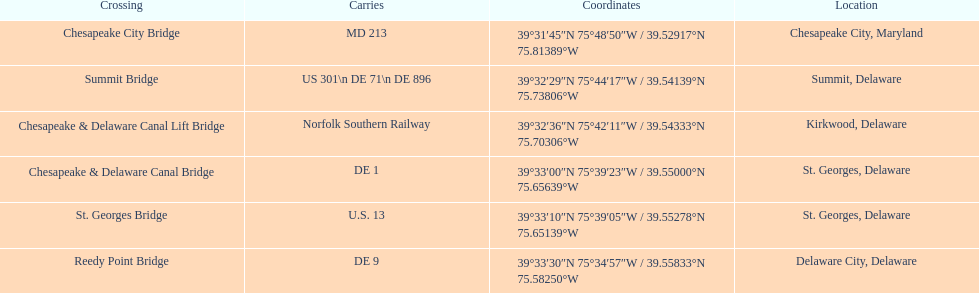Which bridge has their location in summit, delaware? Summit Bridge. Could you parse the entire table as a dict? {'header': ['Crossing', 'Carries', 'Coordinates', 'Location'], 'rows': [['Chesapeake City Bridge', 'MD 213', '39°31′45″N 75°48′50″W\ufeff / \ufeff39.52917°N 75.81389°W', 'Chesapeake City, Maryland'], ['Summit Bridge', 'US 301\\n DE 71\\n DE 896', '39°32′29″N 75°44′17″W\ufeff / \ufeff39.54139°N 75.73806°W', 'Summit, Delaware'], ['Chesapeake & Delaware Canal Lift Bridge', 'Norfolk Southern Railway', '39°32′36″N 75°42′11″W\ufeff / \ufeff39.54333°N 75.70306°W', 'Kirkwood, Delaware'], ['Chesapeake & Delaware Canal Bridge', 'DE 1', '39°33′00″N 75°39′23″W\ufeff / \ufeff39.55000°N 75.65639°W', 'St.\xa0Georges, Delaware'], ['St.\xa0Georges Bridge', 'U.S.\xa013', '39°33′10″N 75°39′05″W\ufeff / \ufeff39.55278°N 75.65139°W', 'St.\xa0Georges, Delaware'], ['Reedy Point Bridge', 'DE\xa09', '39°33′30″N 75°34′57″W\ufeff / \ufeff39.55833°N 75.58250°W', 'Delaware City, Delaware']]} 